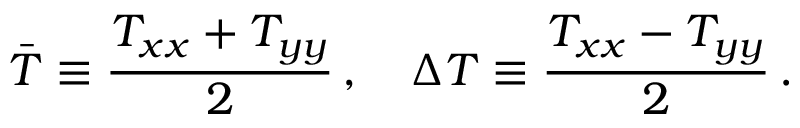Convert formula to latex. <formula><loc_0><loc_0><loc_500><loc_500>\bar { T } \equiv \frac { T _ { x x } + T _ { y y } } { 2 } \, , \Delta T \equiv \frac { T _ { x x } - T _ { y y } } { 2 } \, .</formula> 